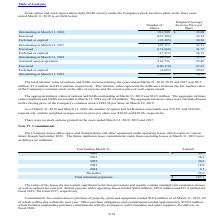According to Microchip Technology's financial document, What was the total intrinsic value of options and SARs exercised during the years ended March 31, 2019? According to the financial document, 8.3 (in millions). The relevant text states: "he years ended March 31, 2019, 2018 and 2017 was $8.3..." Also, What was the number of option and SAR shares exercisable in 2019? According to the financial document, 278,591. The relevant text states: "e number of option and SAR shares exercisable was 278,591 and 224,022,..." Also, Which years does the table provide the number of outstanding shares for? The document contains multiple relevant values: 2016, 2017, 2018, 2019. From the document: "Outstanding at March 31, 2017 433,117 31.51 Outstanding at March 31, 2016 913,508 $ 33.00 ended March 31, 2019 is set forth below: Outstanding at Marc..." Also, How many years did the outstanding number of shares exceed 500,000? Based on the analysis, there are 1 instances. The counting process: 2016. Also, can you calculate: What was the change in the Weighted Average Exercise Price per Share for outstanding shares between 2017 and 2018? Based on the calculation: 31.21-31.51, the result is -0.3. This is based on the information: "Outstanding at March 31, 2017 433,117 31.51 Outstanding at March 31, 2018 284,340 31.21..." The key data points involved are: 31.21, 31.51. Also, can you calculate: What was the percentage change in the number of outstanding shares between 2018 and 2019? To answer this question, I need to perform calculations using the financial data. The calculation is: (281,882-284,340)/284,340, which equals -0.86 (percentage). This is based on the information: "Outstanding at March 31, 2018 284,340 31.21 Outstanding at March 31, 2019 281,882 $ 30.16..." The key data points involved are: 281,882, 284,340. 